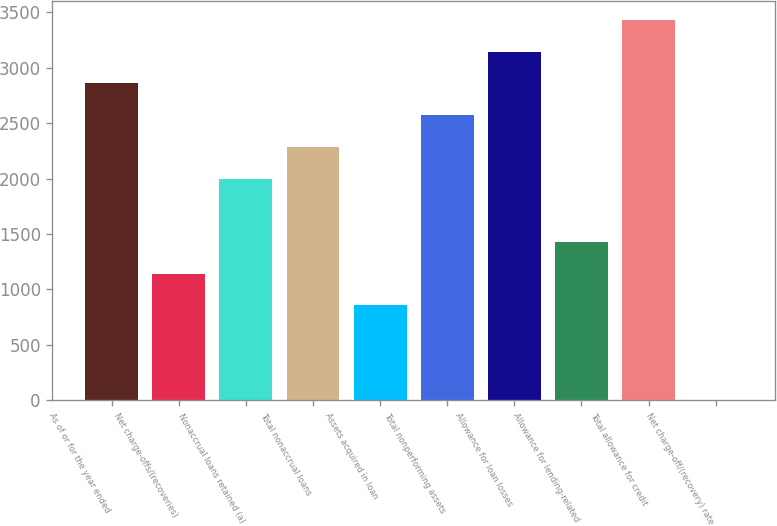<chart> <loc_0><loc_0><loc_500><loc_500><bar_chart><fcel>As of or for the year ended<fcel>Net charge-offs/(recoveries)<fcel>Nonaccrual loans retained (a)<fcel>Total nonaccrual loans<fcel>Assets acquired in loan<fcel>Total nonperforming assets<fcel>Allowance for loan losses<fcel>Allowance for lending-related<fcel>Total allowance for credit<fcel>Net charge-off/(recovery) rate<nl><fcel>2858.02<fcel>1143.22<fcel>2000.62<fcel>2286.42<fcel>857.42<fcel>2572.22<fcel>3143.82<fcel>1429.02<fcel>3429.62<fcel>0.02<nl></chart> 